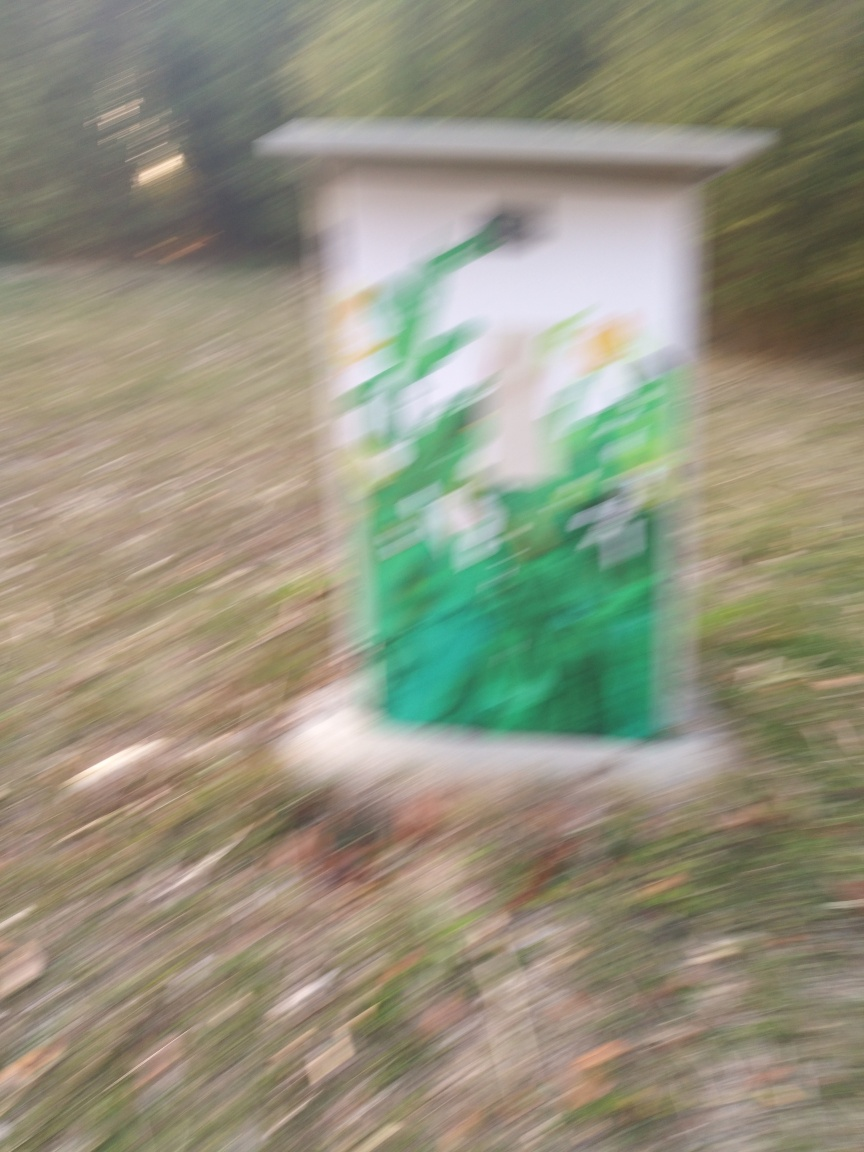Can you describe the setting or environment where this photo was taken? The photo appears to have been taken outdoors, in a natural environment with some grass and foliage visible. Unfortunately, due to the image's blurriness, specific details about the setting are not clear. 